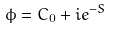Convert formula to latex. <formula><loc_0><loc_0><loc_500><loc_500>\phi = C _ { 0 } + i e ^ { - S }</formula> 